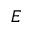<formula> <loc_0><loc_0><loc_500><loc_500>E</formula> 